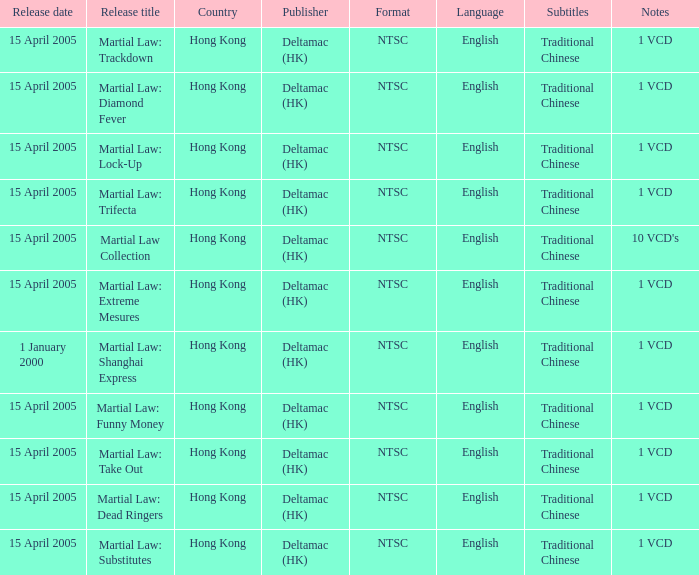When is martial law: take out set to be released? 15 April 2005. 